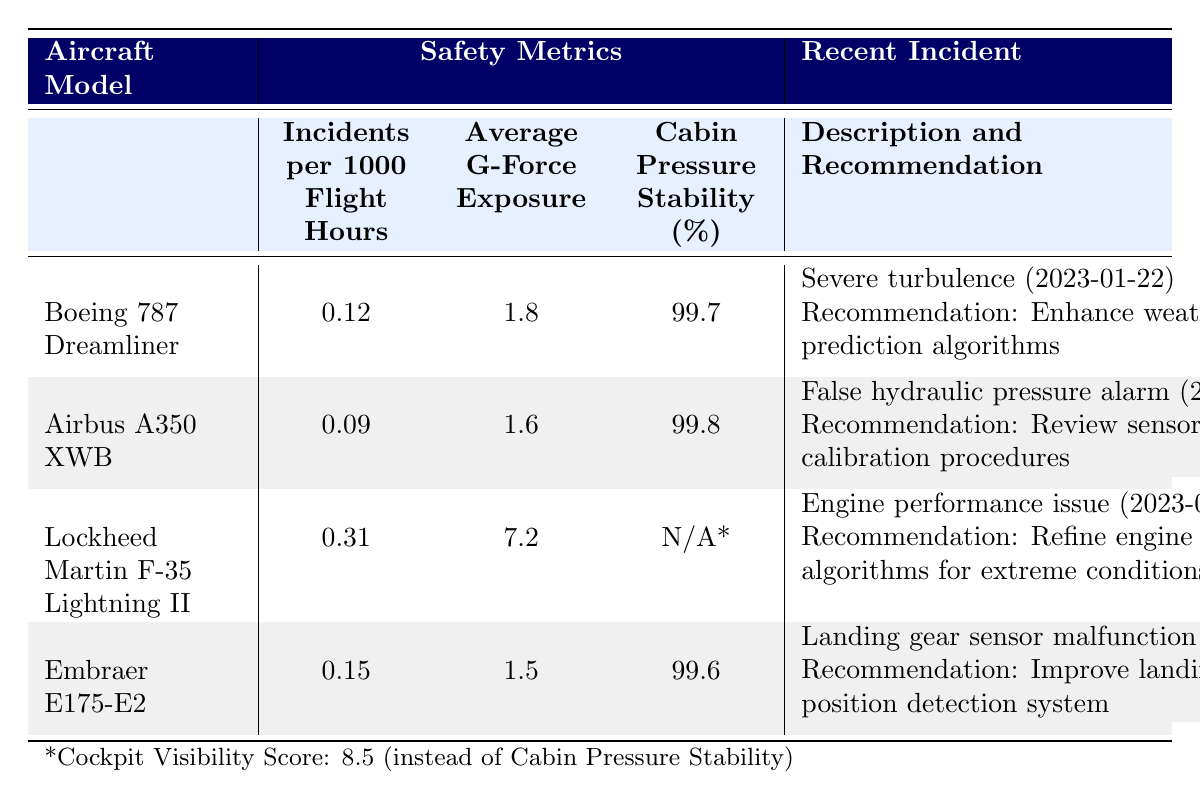What is the incident rate per 1000 flight hours for the Airbus A350 XWB? The table shows that the Airbus A350 XWB has an incident rate of 0.09 incidents per 1000 flight hours.
Answer: 0.09 Which aircraft model has the highest average G-force exposure? According to the table, the Lockheed Martin F-35 Lightning II has the highest average G-force exposure at 7.2.
Answer: Lockheed Martin F-35 Lightning II Is the cabin pressure stability for the Boeing 787 Dreamliner higher than that of the Embraer E175-E2? The table lists the cabin pressure stability for the Boeing 787 Dreamliner as 99.7% and for the Embraer E175-E2 as 99.6%. Since 99.7% is greater than 99.6%, the Boeing 787 Dreamliner has higher stability.
Answer: Yes What is the total number of incidents reported for all aircraft models listed? The Boeing 787 Dreamliner has 2 incidents, the Airbus A350 XWB has 1 incident, the Lockheed Martin F-35 Lightning II has 2 incidents, and the Embraer E175-E2 has 1 incident. Adding these gives: 2 + 1 + 2 + 1 = 6.
Answer: 6 For which aircraft model have pilots recommended improving redundancy in display systems? The table indicates that for the Boeing 787 Dreamliner, pilots recommended improving redundancy in display systems due to a minor system malfunction.
Answer: Boeing 787 Dreamliner What is the average incidents per 1000 flight hours for all the aircraft listed? The incident rates per 1000 flight hours are 0.12 for the Boeing 787, 0.09 for the Airbus A350, 0.31 for the F-35, and 0.15 for the Embraer. Summing these gives 0.12 + 0.09 + 0.31 + 0.15 = 0.67, and dividing by 4 gives an average of 0.67 / 4 = 0.1675.
Answer: 0.1675 Does the Embraer E175-E2 have a cabin pressure stability percentage lower than that of the Boeing 787 Dreamliner? The cabin pressure stability for the Embraer E175-E2 is 99.6% and for the Boeing 787 it is 99.7%. Since 99.6% is less than 99.7%, the Embraer E175-E2 does have lower stability.
Answer: Yes What recommendations were made for the incident involving a software glitch in the Lockheed Martin F-35 Lightning II? The table notes that for the software glitch incident on August 17, 2022, pilots recommended implementing additional failsafes in avionics software.
Answer: Implement additional failsafes in avionics software Which aircraft had an incident related to a hydraulic system warning and when did it occur? The table shows that the Airbus A350 XWB had a hydraulic system warning incident on November 3, 2022, characterized by a false alarm in the hydraulic pressure indicator.
Answer: Airbus A350 XWB, November 3, 2022 What is the difference in cabin pressure stability between the Airbus A350 XWB and the Embraer E175-E2? The Airbus A350 XWB has a cabin pressure stability of 99.8% and the Embraer E175-E2 has 99.6%. The difference is 99.8% - 99.6% = 0.2%.
Answer: 0.2% Which incident for the Boeing 787 Dreamliner was weather-related and what was the pilot's recommendation? The table identifies the incident on January 22, 2023, involving weather-related turbulence, with the recommendations to enhance weather prediction algorithms.
Answer: Enhance weather prediction algorithms 